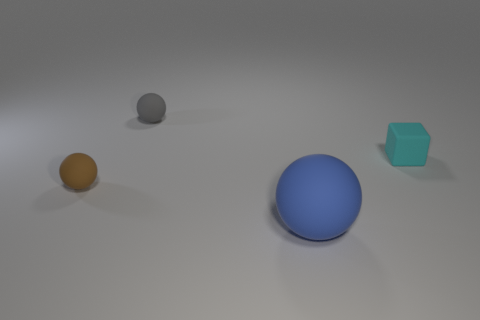Subtract all tiny matte spheres. How many spheres are left? 1 Subtract all blue balls. How many balls are left? 2 Subtract all cubes. How many objects are left? 3 Add 1 small brown matte spheres. How many objects exist? 5 Subtract all purple blocks. How many green spheres are left? 0 Subtract all tiny cyan things. Subtract all brown matte objects. How many objects are left? 2 Add 4 brown balls. How many brown balls are left? 5 Add 3 large green things. How many large green things exist? 3 Subtract 0 gray cylinders. How many objects are left? 4 Subtract 1 cubes. How many cubes are left? 0 